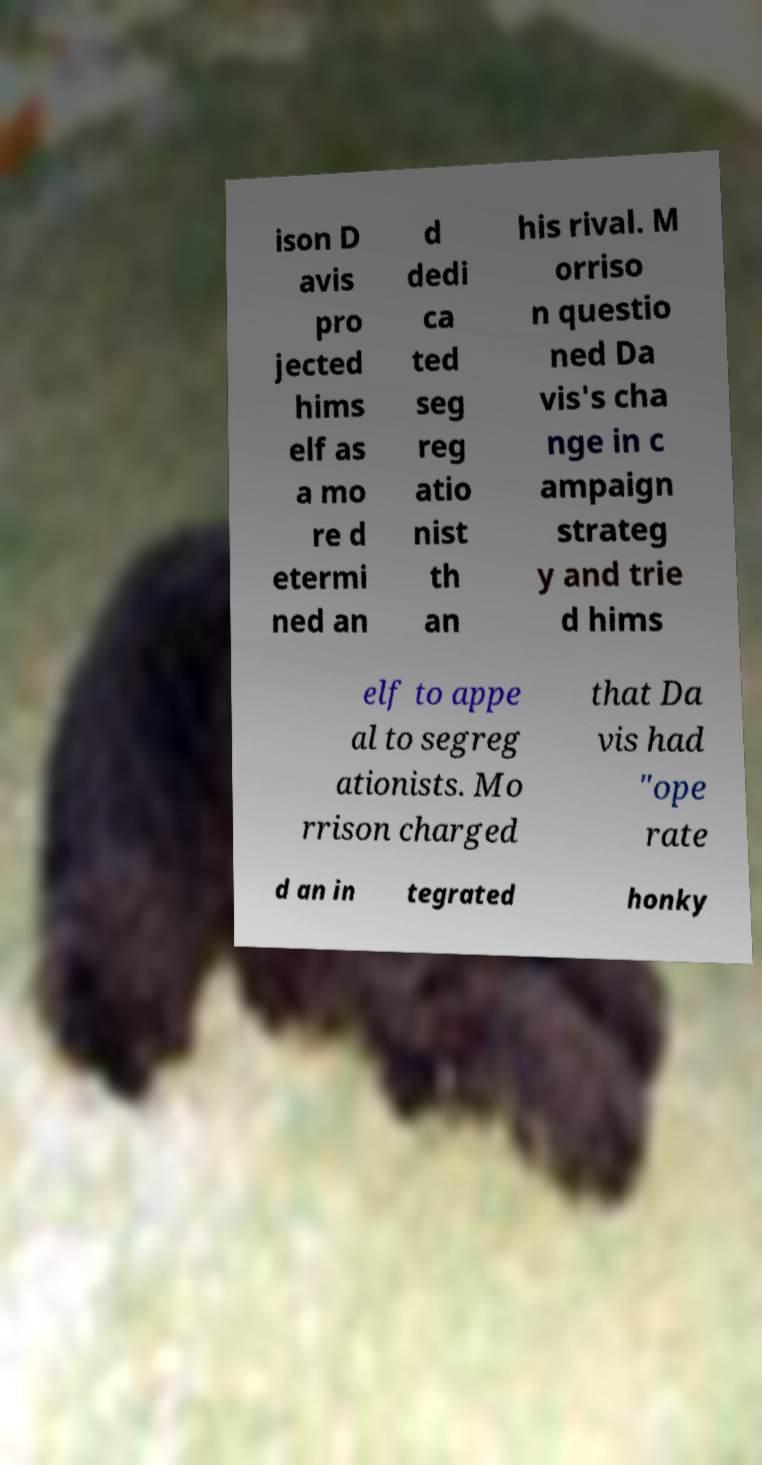There's text embedded in this image that I need extracted. Can you transcribe it verbatim? ison D avis pro jected hims elf as a mo re d etermi ned an d dedi ca ted seg reg atio nist th an his rival. M orriso n questio ned Da vis's cha nge in c ampaign strateg y and trie d hims elf to appe al to segreg ationists. Mo rrison charged that Da vis had "ope rate d an in tegrated honky 